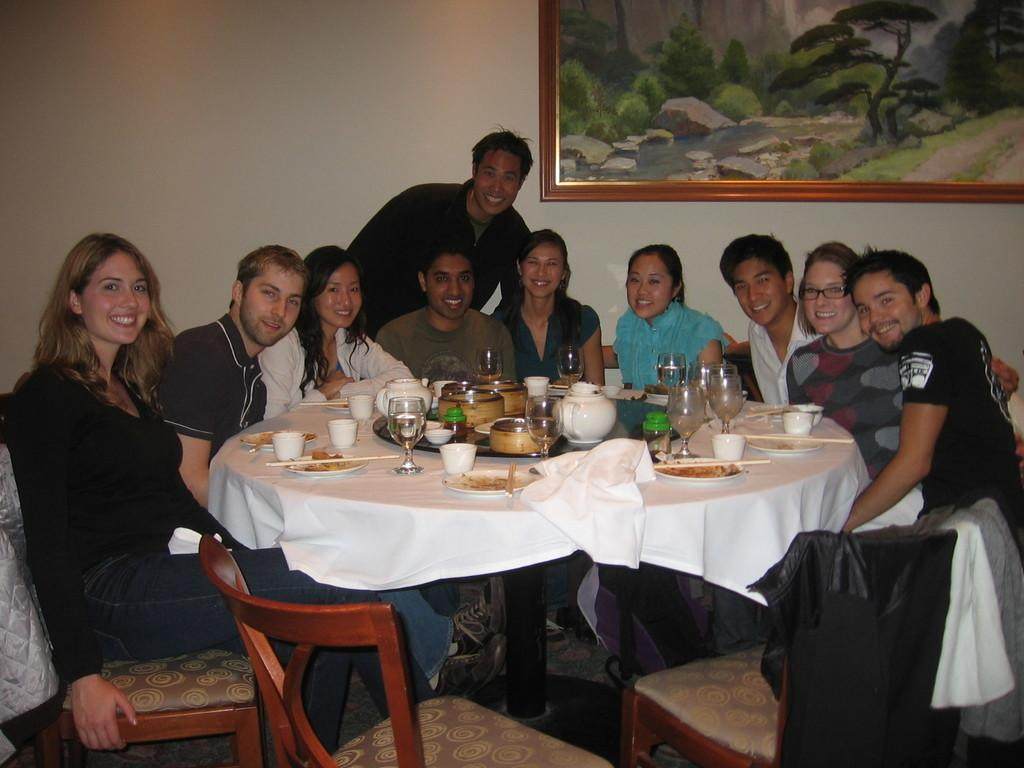How many people are in the image? There is a group of people in the image. What are the people doing in the image? The people are sitting on chairs. What is on the table in front of the people? There is food on a table in front of the people. What else can be seen on the table? There are glasses on the table. What can be seen in the background of the image? There is a painting visible in the background. How many icicles are hanging from the painting in the image? There are no icicles visible in the image, as it is indoors and not cold enough for icicles to form. 